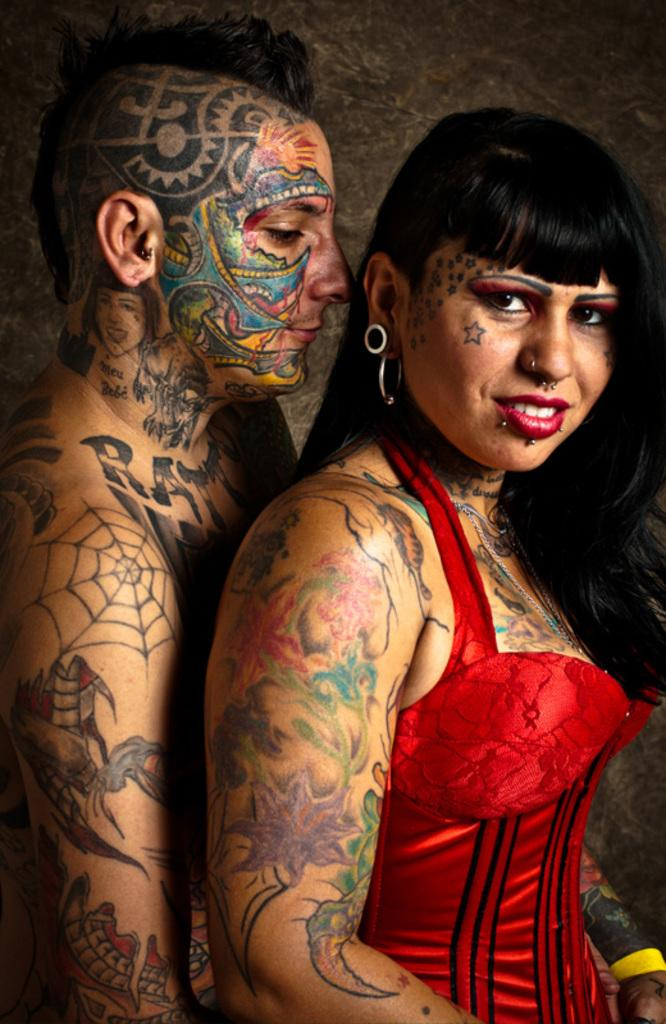Who or what is present in the image? There are people in the image. What distinguishing feature can be observed on the people? The people have tattoos. What can be seen in the background of the image? There is a wall in the background of the image. What type of bread can be seen in the image? There is no bread present in the image. How many birds are visible in the image? There are no birds visible in the image. 